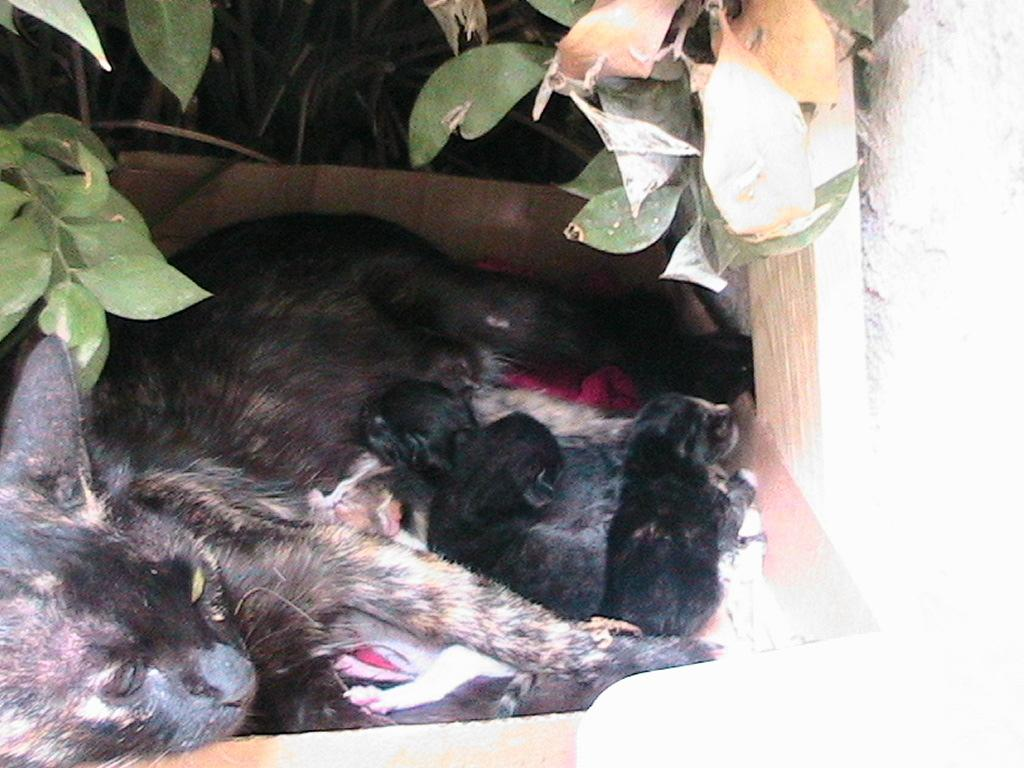What type of animal is in the image? There is a cat in the image. Are there any other animals near the cat? Yes, there are puppies near the cat. What can be seen in the background of the image? There is a plant and leaves present in the background of the image. What type of flower is being read by the cat in the image? There is no flower present in the image, and the cat is not reading anything. 